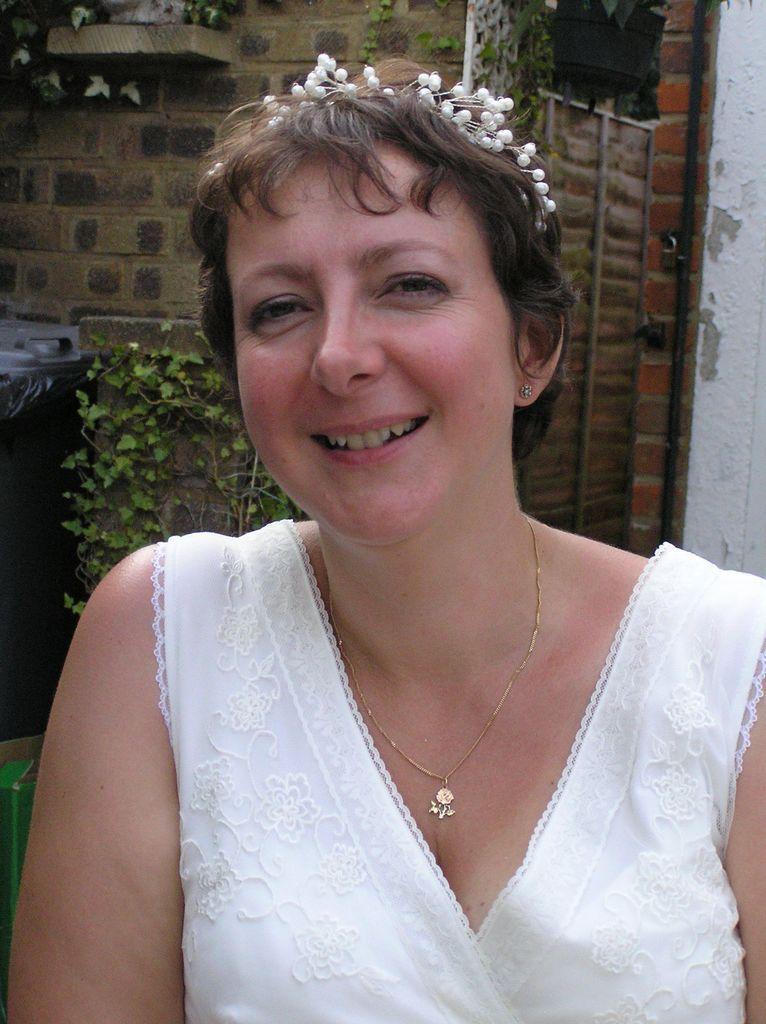In one or two sentences, can you explain what this image depicts? In this picture we can see a woman in the white dress is smiling. Behind the woman there is a wall with pipes and a plant. In front of the wall there is a plant and a dustbin. 